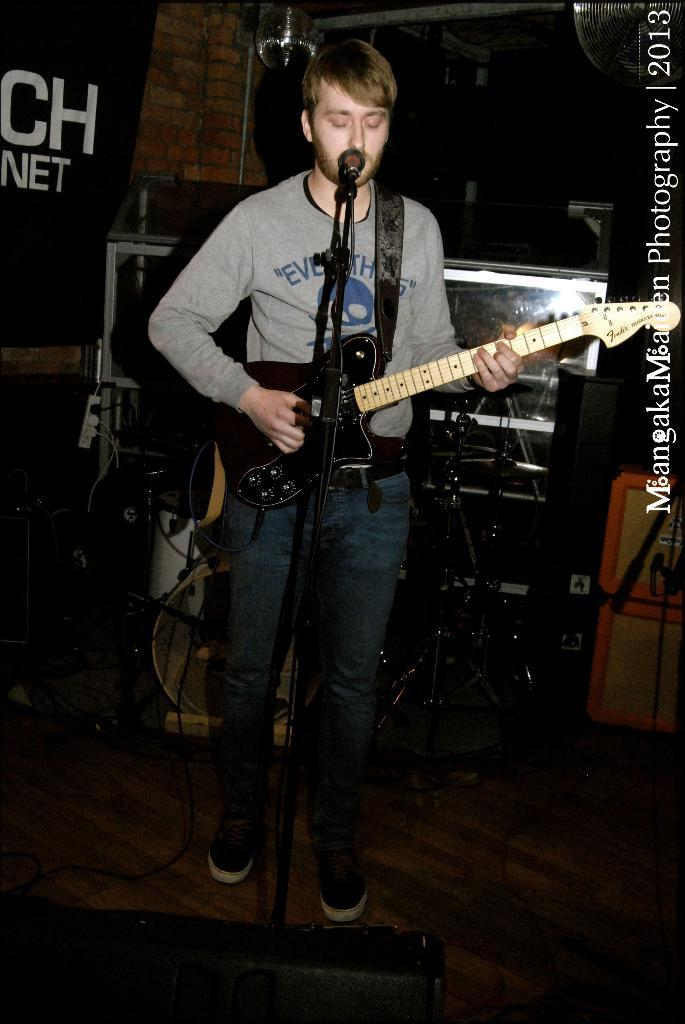What is the person in the image doing? The person is standing in the image and holding a guitar. Where is the person located in the image? The person is at a microphone. What can be seen in the background of the image? There are monitors, musical instruments, a banner, and a wall in the background of the image. What type of cherries are being used as a fan in the image? There are no cherries or fans present in the image. Can you describe the person's nose in the image? The person's nose is not mentioned in the provided facts, so it cannot be described. 